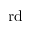<formula> <loc_0><loc_0><loc_500><loc_500>r d</formula> 